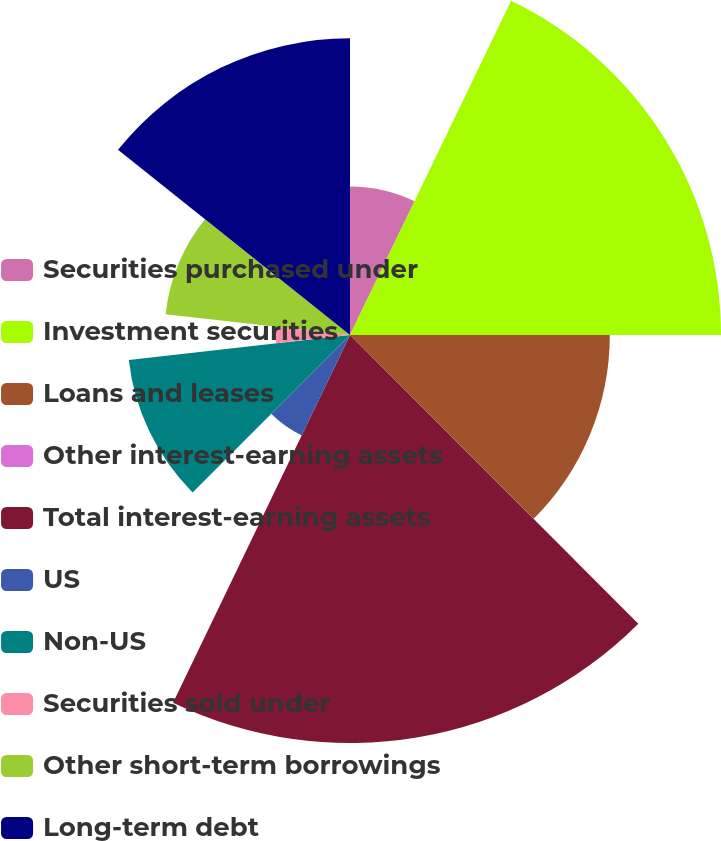Convert chart to OTSL. <chart><loc_0><loc_0><loc_500><loc_500><pie_chart><fcel>Securities purchased under<fcel>Investment securities<fcel>Loans and leases<fcel>Other interest-earning assets<fcel>Total interest-earning assets<fcel>US<fcel>Non-US<fcel>Securities sold under<fcel>Other short-term borrowings<fcel>Long-term debt<nl><fcel>7.15%<fcel>17.85%<fcel>12.5%<fcel>0.01%<fcel>19.63%<fcel>5.36%<fcel>10.71%<fcel>3.58%<fcel>8.93%<fcel>14.28%<nl></chart> 